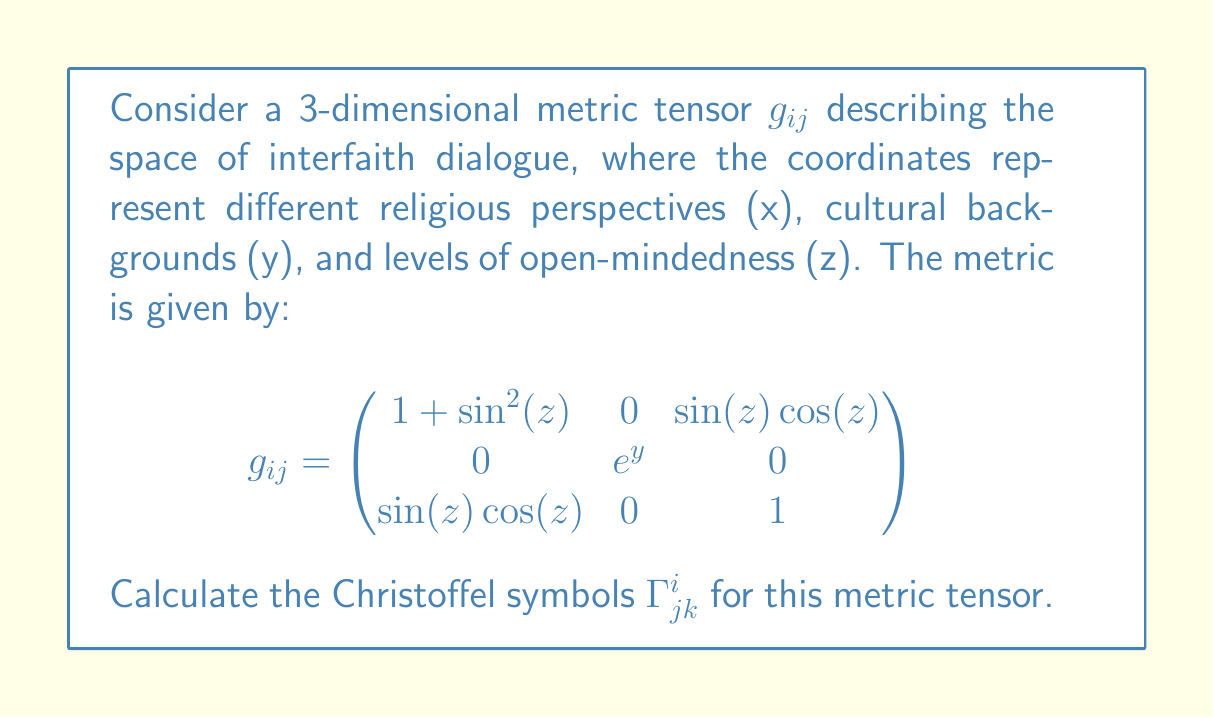Help me with this question. To calculate the Christoffel symbols, we use the formula:

$$\Gamma^i_{jk} = \frac{1}{2}g^{im}\left(\frac{\partial g_{mj}}{\partial x^k} + \frac{\partial g_{mk}}{\partial x^j} - \frac{\partial g_{jk}}{\partial x^m}\right)$$

Step 1: Calculate the inverse metric tensor $g^{ij}$:
$$g^{ij} = \begin{pmatrix}
1 & 0 & -\sin(z)\cos(z) \\
0 & e^{-y} & 0 \\
-\sin(z)\cos(z) & 0 & 1 + \sin^2(z)
\end{pmatrix}$$

Step 2: Calculate the partial derivatives of $g_{ij}$:
$\frac{\partial g_{11}}{\partial z} = 2\sin(z)\cos(z)$
$\frac{\partial g_{13}}{\partial z} = \cos^2(z) - \sin^2(z)$
$\frac{\partial g_{22}}{\partial y} = e^y$
All other partial derivatives are zero.

Step 3: Calculate the non-zero Christoffel symbols:

$\Gamma^1_{33} = \frac{1}{2}g^{11}\frac{\partial g_{11}}{\partial z} = \sin(z)\cos(z)$

$\Gamma^1_{13} = \Gamma^1_{31} = \frac{1}{2}g^{11}\frac{\partial g_{11}}{\partial z} = \sin(z)\cos(z)$

$\Gamma^3_{11} = -\frac{1}{2}g^{33}\frac{\partial g_{11}}{\partial z} = -\sin(z)\cos(z)(1+\sin^2(z))$

$\Gamma^3_{13} = \Gamma^3_{31} = \frac{1}{2}g^{33}\left(\frac{\partial g_{13}}{\partial z} - \frac{\partial g_{11}}{\partial z}\right) = -\frac{1}{2}(1+\sin^2(z))(\sin^2(z)-\cos^2(z))$

$\Gamma^2_{22} = \frac{1}{2}g^{22}\frac{\partial g_{22}}{\partial y} = \frac{1}{2}$

All other Christoffel symbols are zero.
Answer: $\Gamma^1_{33} = \Gamma^1_{13} = \Gamma^1_{31} = \sin(z)\cos(z)$
$\Gamma^3_{11} = -\sin(z)\cos(z)(1+\sin^2(z))$
$\Gamma^3_{13} = \Gamma^3_{31} = -\frac{1}{2}(1+\sin^2(z))(\sin^2(z)-\cos^2(z))$
$\Gamma^2_{22} = \frac{1}{2}$ 